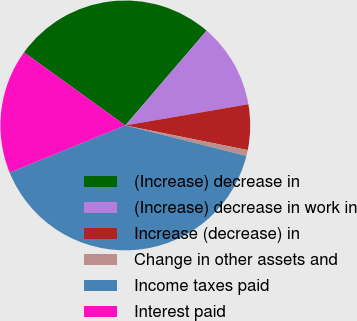Convert chart to OTSL. <chart><loc_0><loc_0><loc_500><loc_500><pie_chart><fcel>(Increase) decrease in<fcel>(Increase) decrease in work in<fcel>Increase (decrease) in<fcel>Change in other assets and<fcel>Income taxes paid<fcel>Interest paid<nl><fcel>26.34%<fcel>11.0%<fcel>5.88%<fcel>0.77%<fcel>39.9%<fcel>16.11%<nl></chart> 